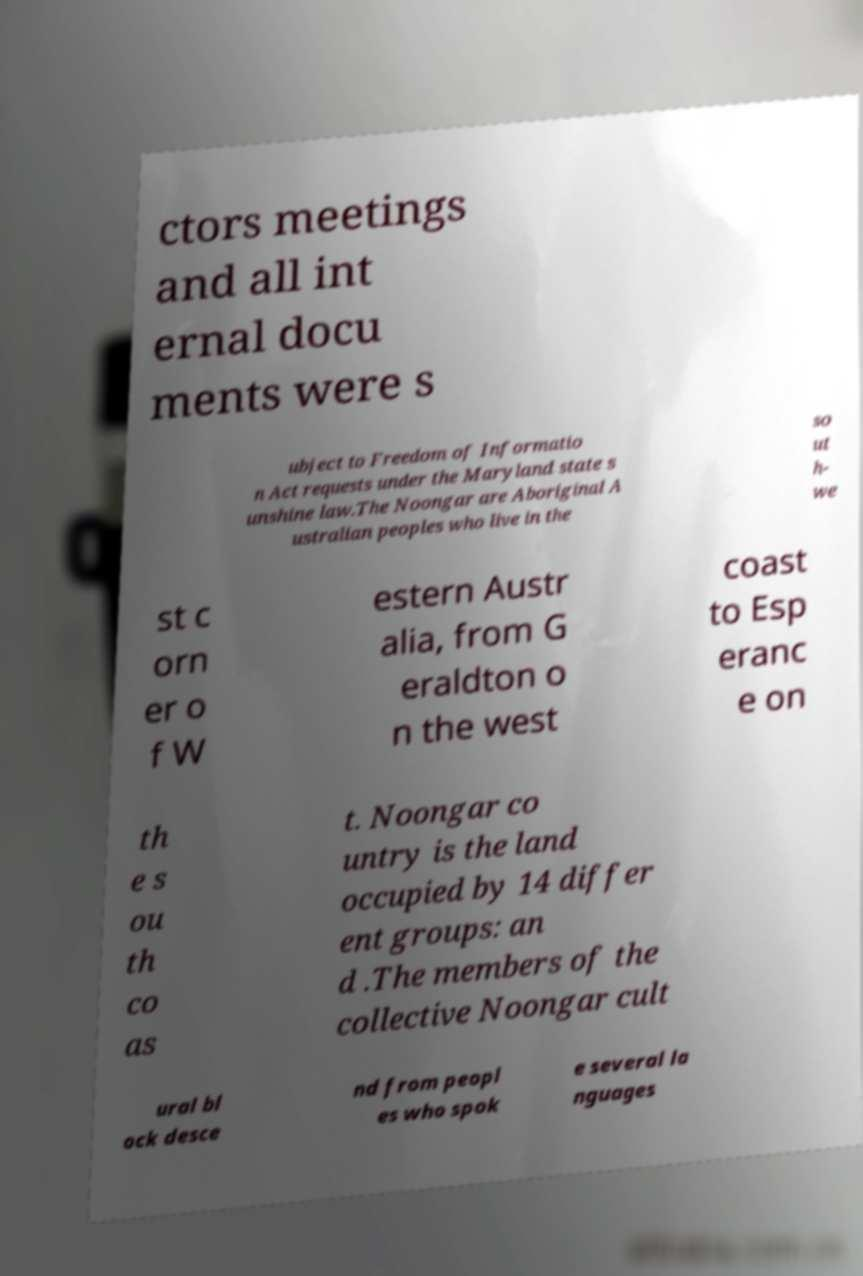Please identify and transcribe the text found in this image. ctors meetings and all int ernal docu ments were s ubject to Freedom of Informatio n Act requests under the Maryland state s unshine law.The Noongar are Aboriginal A ustralian peoples who live in the so ut h- we st c orn er o f W estern Austr alia, from G eraldton o n the west coast to Esp eranc e on th e s ou th co as t. Noongar co untry is the land occupied by 14 differ ent groups: an d .The members of the collective Noongar cult ural bl ock desce nd from peopl es who spok e several la nguages 